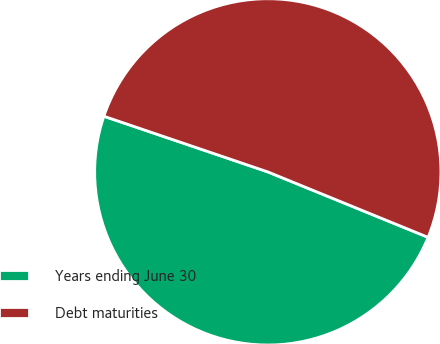Convert chart. <chart><loc_0><loc_0><loc_500><loc_500><pie_chart><fcel>Years ending June 30<fcel>Debt maturities<nl><fcel>49.04%<fcel>50.96%<nl></chart> 